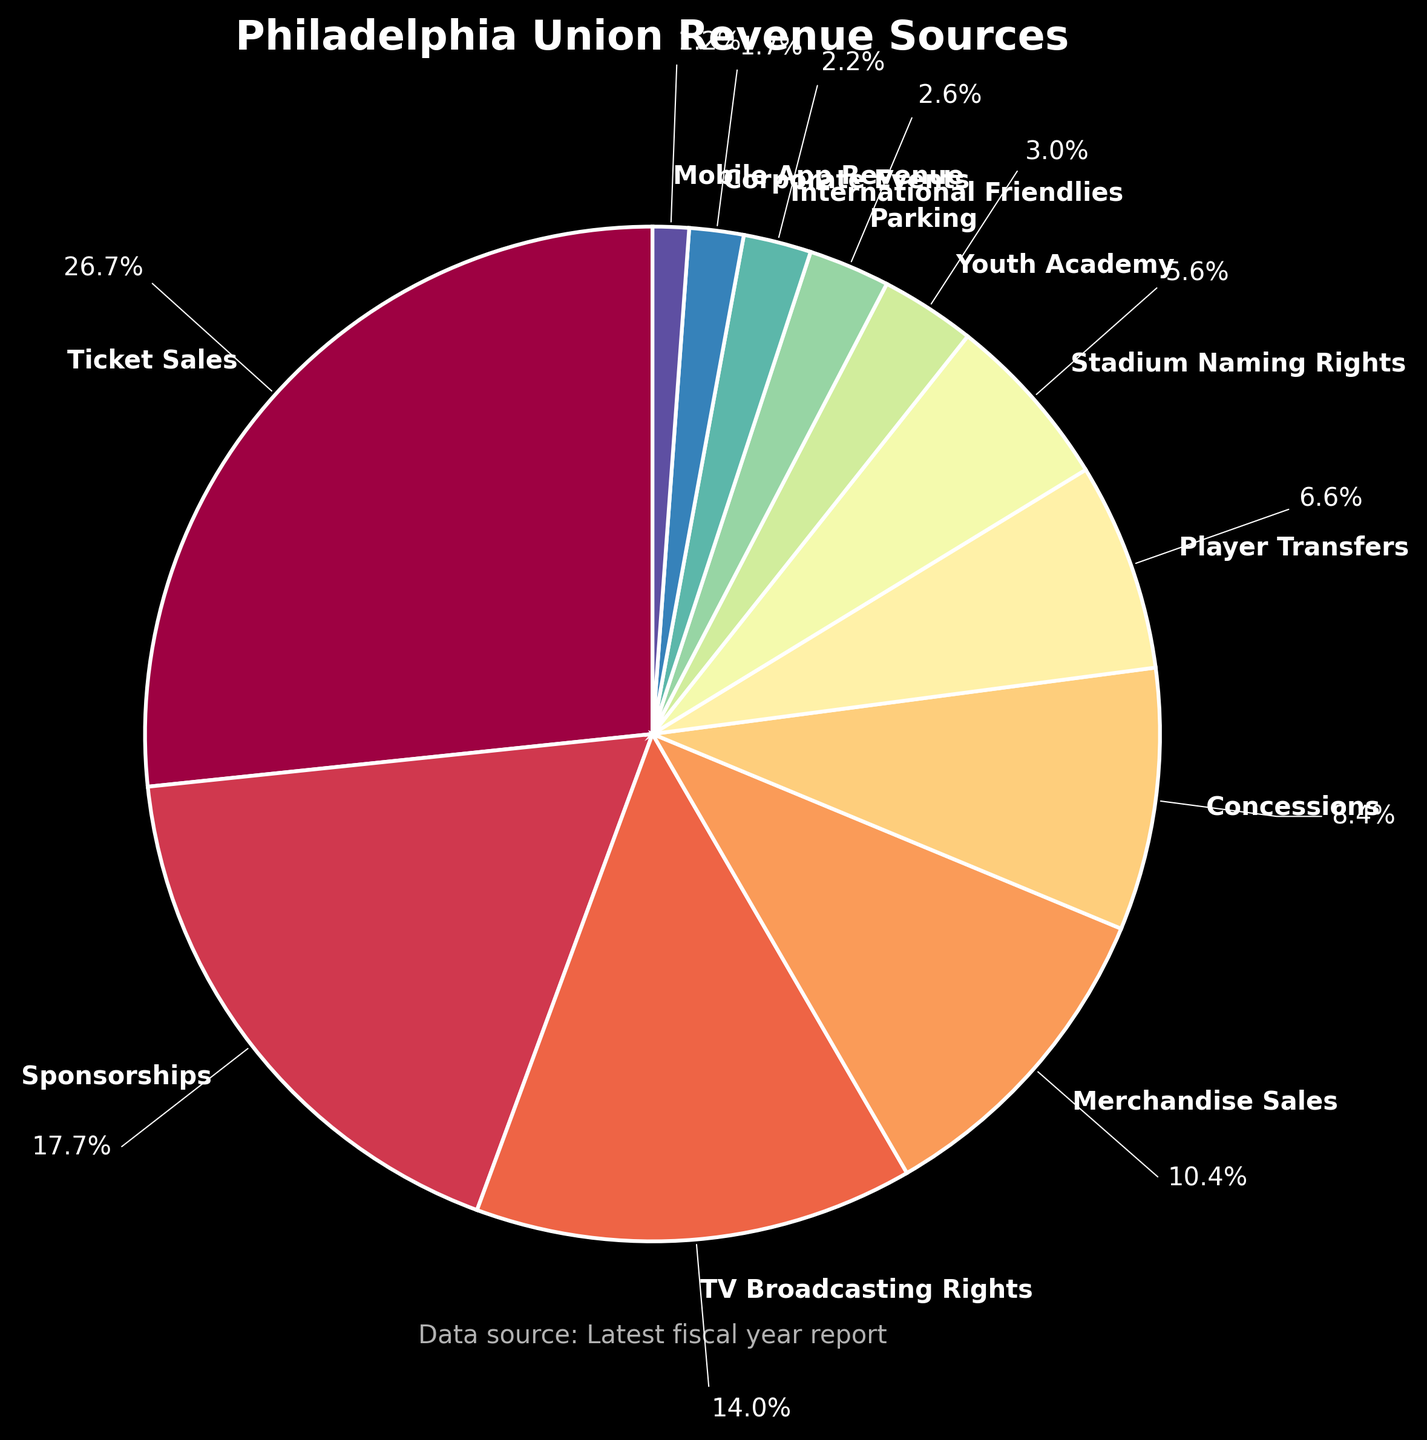Which revenue source contributes the most to Philadelphia Union's total revenue? To determine the largest revenue source, look for the section of the pie with the largest area. The section for Ticket Sales covers the most area, indicating it's the largest contributor.
Answer: Ticket Sales What percentage of the total revenue comes from Merchandise Sales? Find the section of the pie labeled Merchandise Sales and note the percentage outside the pie slice. Merchandise Sales is labeled with 7.2 million; the corresponding percentage is calculated and displayed near the slice.
Answer: 12.5% Which two revenue sources combined give a total amount closest to the amount from Ticket Sales? Ticket Sales amount is 18.5 million. Adding the amounts of other revenue sources like Sponsorships (12.3 million) and Merchandise Sales (7.2 million) equals 19.5 million, which is closest to the 18.5 million from Ticket Sales.
Answer: Sponsorships and Merchandise Sales Is the revenue from Player Transfers greater than or less than the revenue from Concessions? Compare the sections of the pie labeled Player Transfers and Concessions. Player Transfers (4.6 million) is less than Concessions (5.8 million).
Answer: Less How much more revenue does TV Broadcasting Rights generate compared to Concessions? Subtract the revenue from Concessions from TV Broadcasting Rights. TV Broadcasting Rights (9.7 million) minus Concessions (5.8 million) equals 3.9 million.
Answer: 3.9 million What is the total revenue generated by the bottom three revenue sources combined? Identify the three smallest segments: Mobile App Revenue (0.8 million), Corporate Events (1.2 million), and International Friendlies (1.5 million). Add their amounts together: 0.8 + 1.2 + 1.5 = 3.5 million.
Answer: 3.5 million Which section of the pie is visually the smallest and what is its revenue? The smallest section of the pie corresponds to Mobile App Revenue, generating 0.8 million.
Answer: Mobile App Revenue, 0.8 million If Ticket Sales and Sponsorships' revenue are combined, what fraction of the total revenue do they represent? Add Ticket Sales (18.5 million) and Sponsorships (12.3 million): 18.5 + 12.3 = 30.8 million. The total revenue is the sum of all amounts (69.4 million). The fraction is 30.8 / 69.4, which simplifies to approximately 0.444.
Answer: Approximately 0.444 (or 44.4%) 